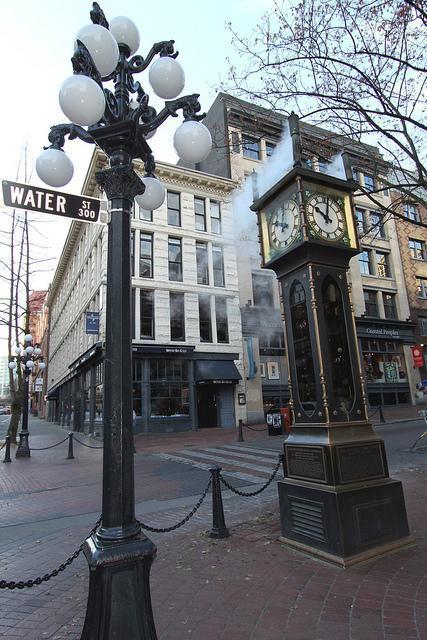How many street signs are there?
Give a very brief answer. 1. How many sheep are there?
Give a very brief answer. 0. 